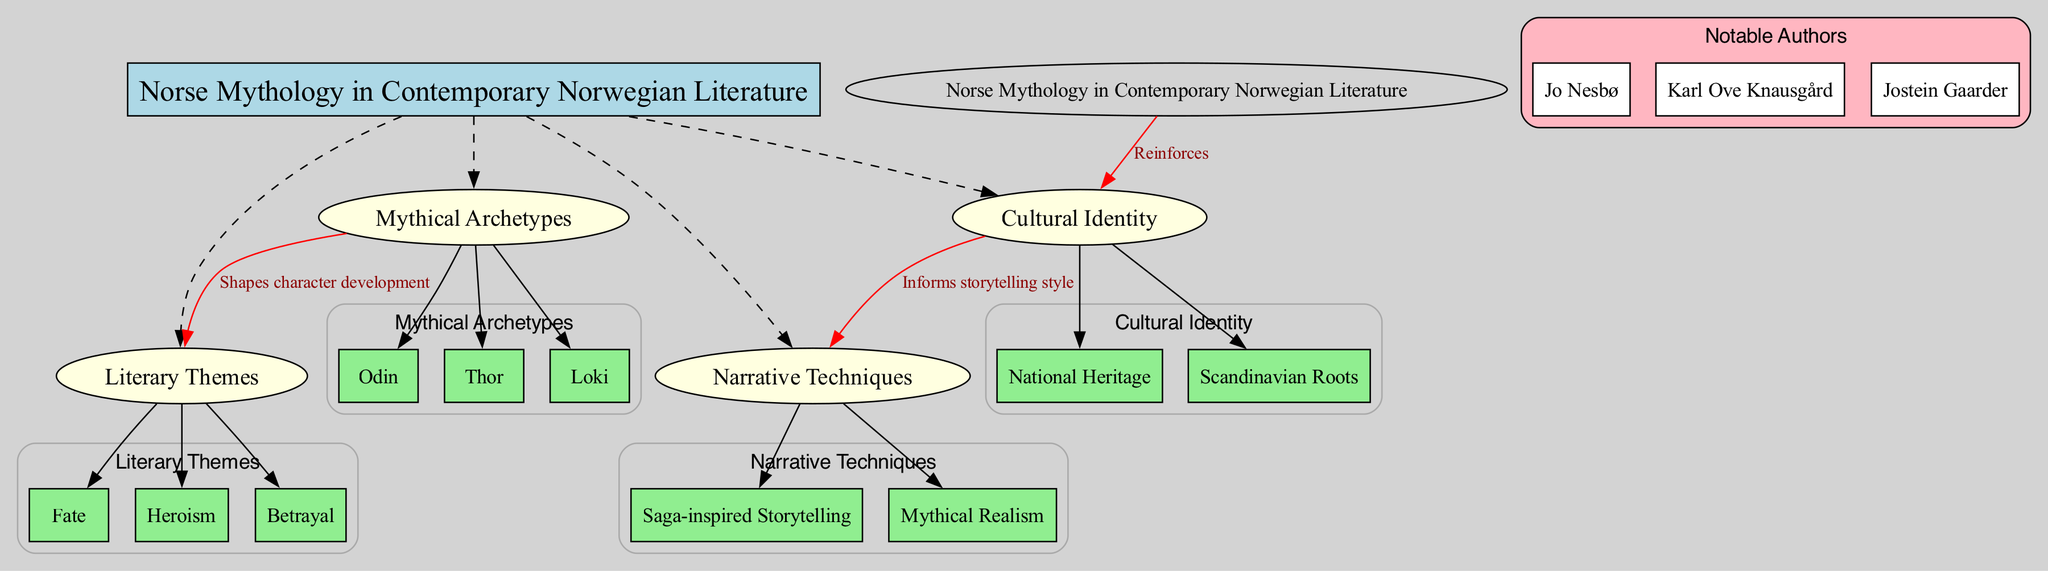What is the central topic of the diagram? The central topic is explicitly labeled in the diagram as "Norse Mythology in Contemporary Norwegian Literature."
Answer: Norse Mythology in Contemporary Norwegian Literature How many main elements are connected to the central topic? The diagram features four main elements (Mythical Archetypes, Literary Themes, Cultural Identity, Narrative Techniques) that are directly connected to the central topic.
Answer: 4 Which mythical archetype is known for trickery? Among the mythical archetypes listed, Loki is commonly associated with trickery and deception.
Answer: Loki What literary theme is shaped by mythical archetypes? The diagram indicates that the theme of Heroism is shaped by the mythical archetypes, as shown by the connection arrow leading from 'Mythical Archetypes' to 'Literary Themes.'
Answer: Heroism What connection is made about cultural identity in relation to narrative techniques? The diagram specifies that cultural identity informs storytelling style, as indicated by the labeled edge connecting 'Cultural Identity' to 'Narrative Techniques.'
Answer: Informs storytelling style Who are the notable authors mentioned in the diagram? The diagram lists three notable authors: Jo Nesbø, Karl Ove Knausgård, and Jostein Gaarder, each within their own node under the section labeled 'Notable Authors.'
Answer: Jo Nesbø, Karl Ove Knausgård, Jostein Gaarder Which main element reinforces cultural identity in the context of the diagram? The central topic explicitly states that "Norse Mythology in Contemporary Norwegian Literature" reinforces cultural identity as indicated by the connection from the central topic to 'Cultural Identity.'
Answer: Reinforces What narrative technique is inspired by sagas? The diagram lists 'Saga-inspired Storytelling' as one of the narrative techniques under the main element 'Narrative Techniques.'
Answer: Saga-inspired Storytelling 